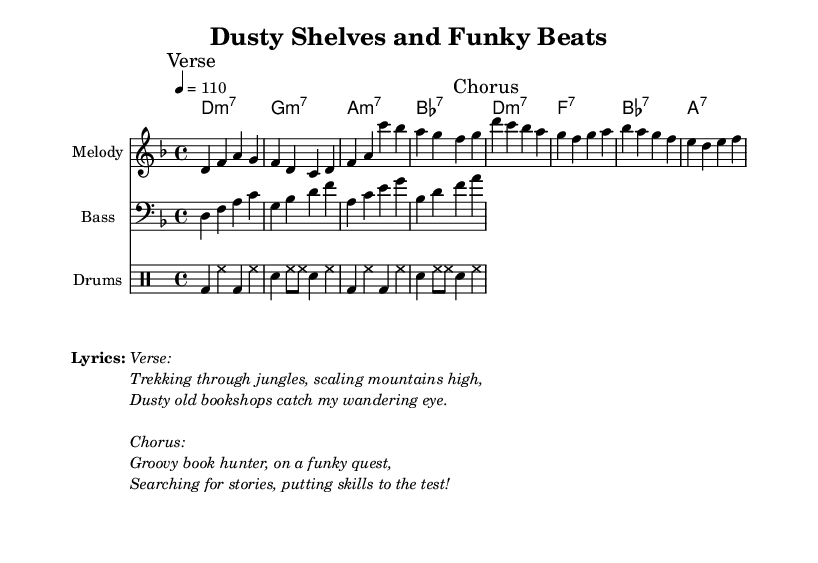What is the key signature of this music? The key signature is indicated by the key signature symbol at the beginning of the staff. It is D minor, which has one flat (B flat).
Answer: D minor What is the time signature of this piece? The time signature is shown at the beginning of the staff as "4/4", which means there are four beats in each measure and a quarter note gets one beat.
Answer: 4/4 What is the tempo marking given in this score? The tempo is specified as "4 = 110", indicating that the quarter note equals a tempo of 110 beats per minute.
Answer: 110 How many measures are in the verse? The verse section contains two lines of music, and each line has four measures, totaling eight measures in the verse.
Answer: Eight Which chords are used in the chorus? The chords for the chorus, as listed in the chord names section, are D minor seven, F seven, B flat seven, and A seven.
Answer: D minor seven, F seven, B flat seven, A seven What is the main rhythm pattern for the drums during the verse? The drum pattern alternates between bass drum and hi-hat, creating a consistent groove throughout the measures of the verse.
Answer: Bass drum and hi-hat What is the lyrical theme of the song? The lyrics reflect a journey of exploration in search of literary treasures, emphasizing adventure and discovery throughout the verses and chorus.
Answer: Literary treasures 